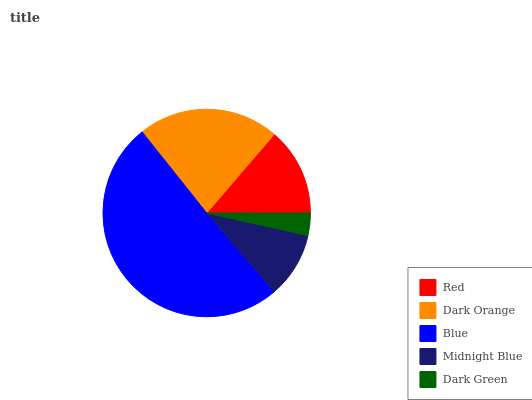Is Dark Green the minimum?
Answer yes or no. Yes. Is Blue the maximum?
Answer yes or no. Yes. Is Dark Orange the minimum?
Answer yes or no. No. Is Dark Orange the maximum?
Answer yes or no. No. Is Dark Orange greater than Red?
Answer yes or no. Yes. Is Red less than Dark Orange?
Answer yes or no. Yes. Is Red greater than Dark Orange?
Answer yes or no. No. Is Dark Orange less than Red?
Answer yes or no. No. Is Red the high median?
Answer yes or no. Yes. Is Red the low median?
Answer yes or no. Yes. Is Blue the high median?
Answer yes or no. No. Is Midnight Blue the low median?
Answer yes or no. No. 